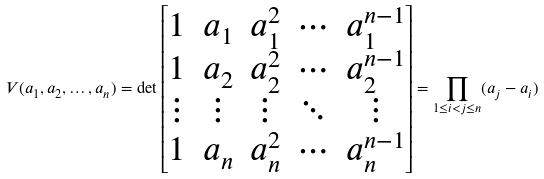Convert formula to latex. <formula><loc_0><loc_0><loc_500><loc_500>V ( a _ { 1 } , a _ { 2 } , \dots , a _ { n } ) = \det \begin{bmatrix} 1 & a _ { 1 } & a _ { 1 } ^ { 2 } & \cdots & a _ { 1 } ^ { n - 1 } \\ 1 & a _ { 2 } & a _ { 2 } ^ { 2 } & \cdots & a _ { 2 } ^ { n - 1 } \\ \vdots & \vdots & \vdots & \ddots & \vdots \\ 1 & a _ { n } & a _ { n } ^ { 2 } & \cdots & a _ { n } ^ { n - 1 } \\ \end{bmatrix} = \prod _ { 1 \leq i < j \leq n } ( a _ { j } - a _ { i } )</formula> 